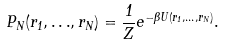<formula> <loc_0><loc_0><loc_500><loc_500>P _ { N } ( r _ { 1 } , { \dots } , r _ { N } ) = \frac { 1 } { Z } e ^ { - \beta U ( r _ { 1 } , { \dots } , r _ { N } ) } .</formula> 